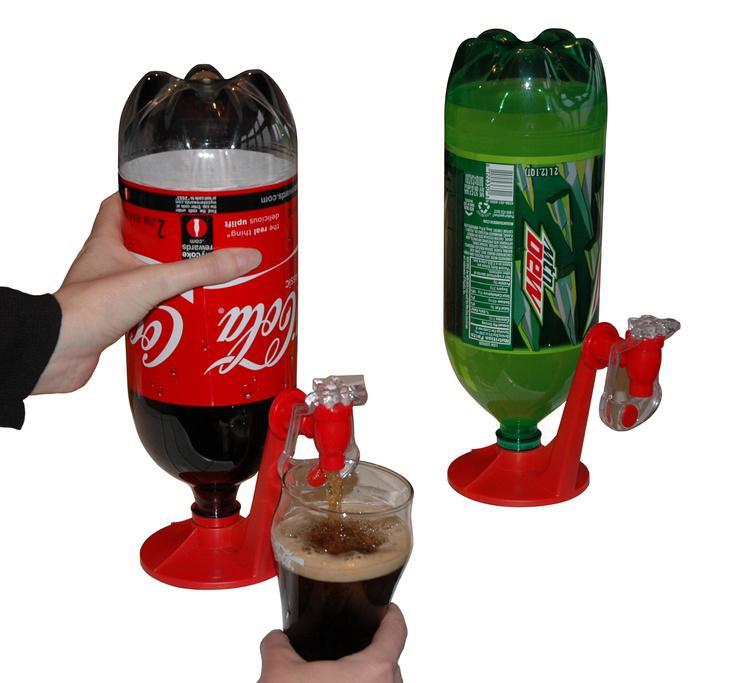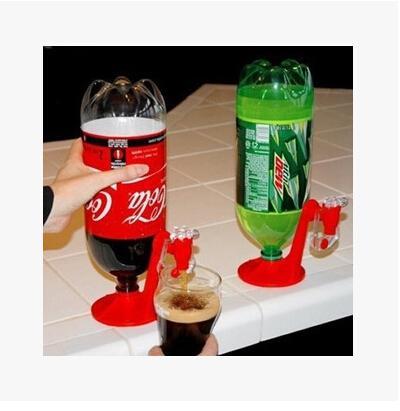The first image is the image on the left, the second image is the image on the right. Analyze the images presented: Is the assertion "The combined images contain seven soda bottles, and no two bottles are exactly the same." valid? Answer yes or no. No. The first image is the image on the left, the second image is the image on the right. Given the left and right images, does the statement "All sodas in the left image have caffeine." hold true? Answer yes or no. Yes. 